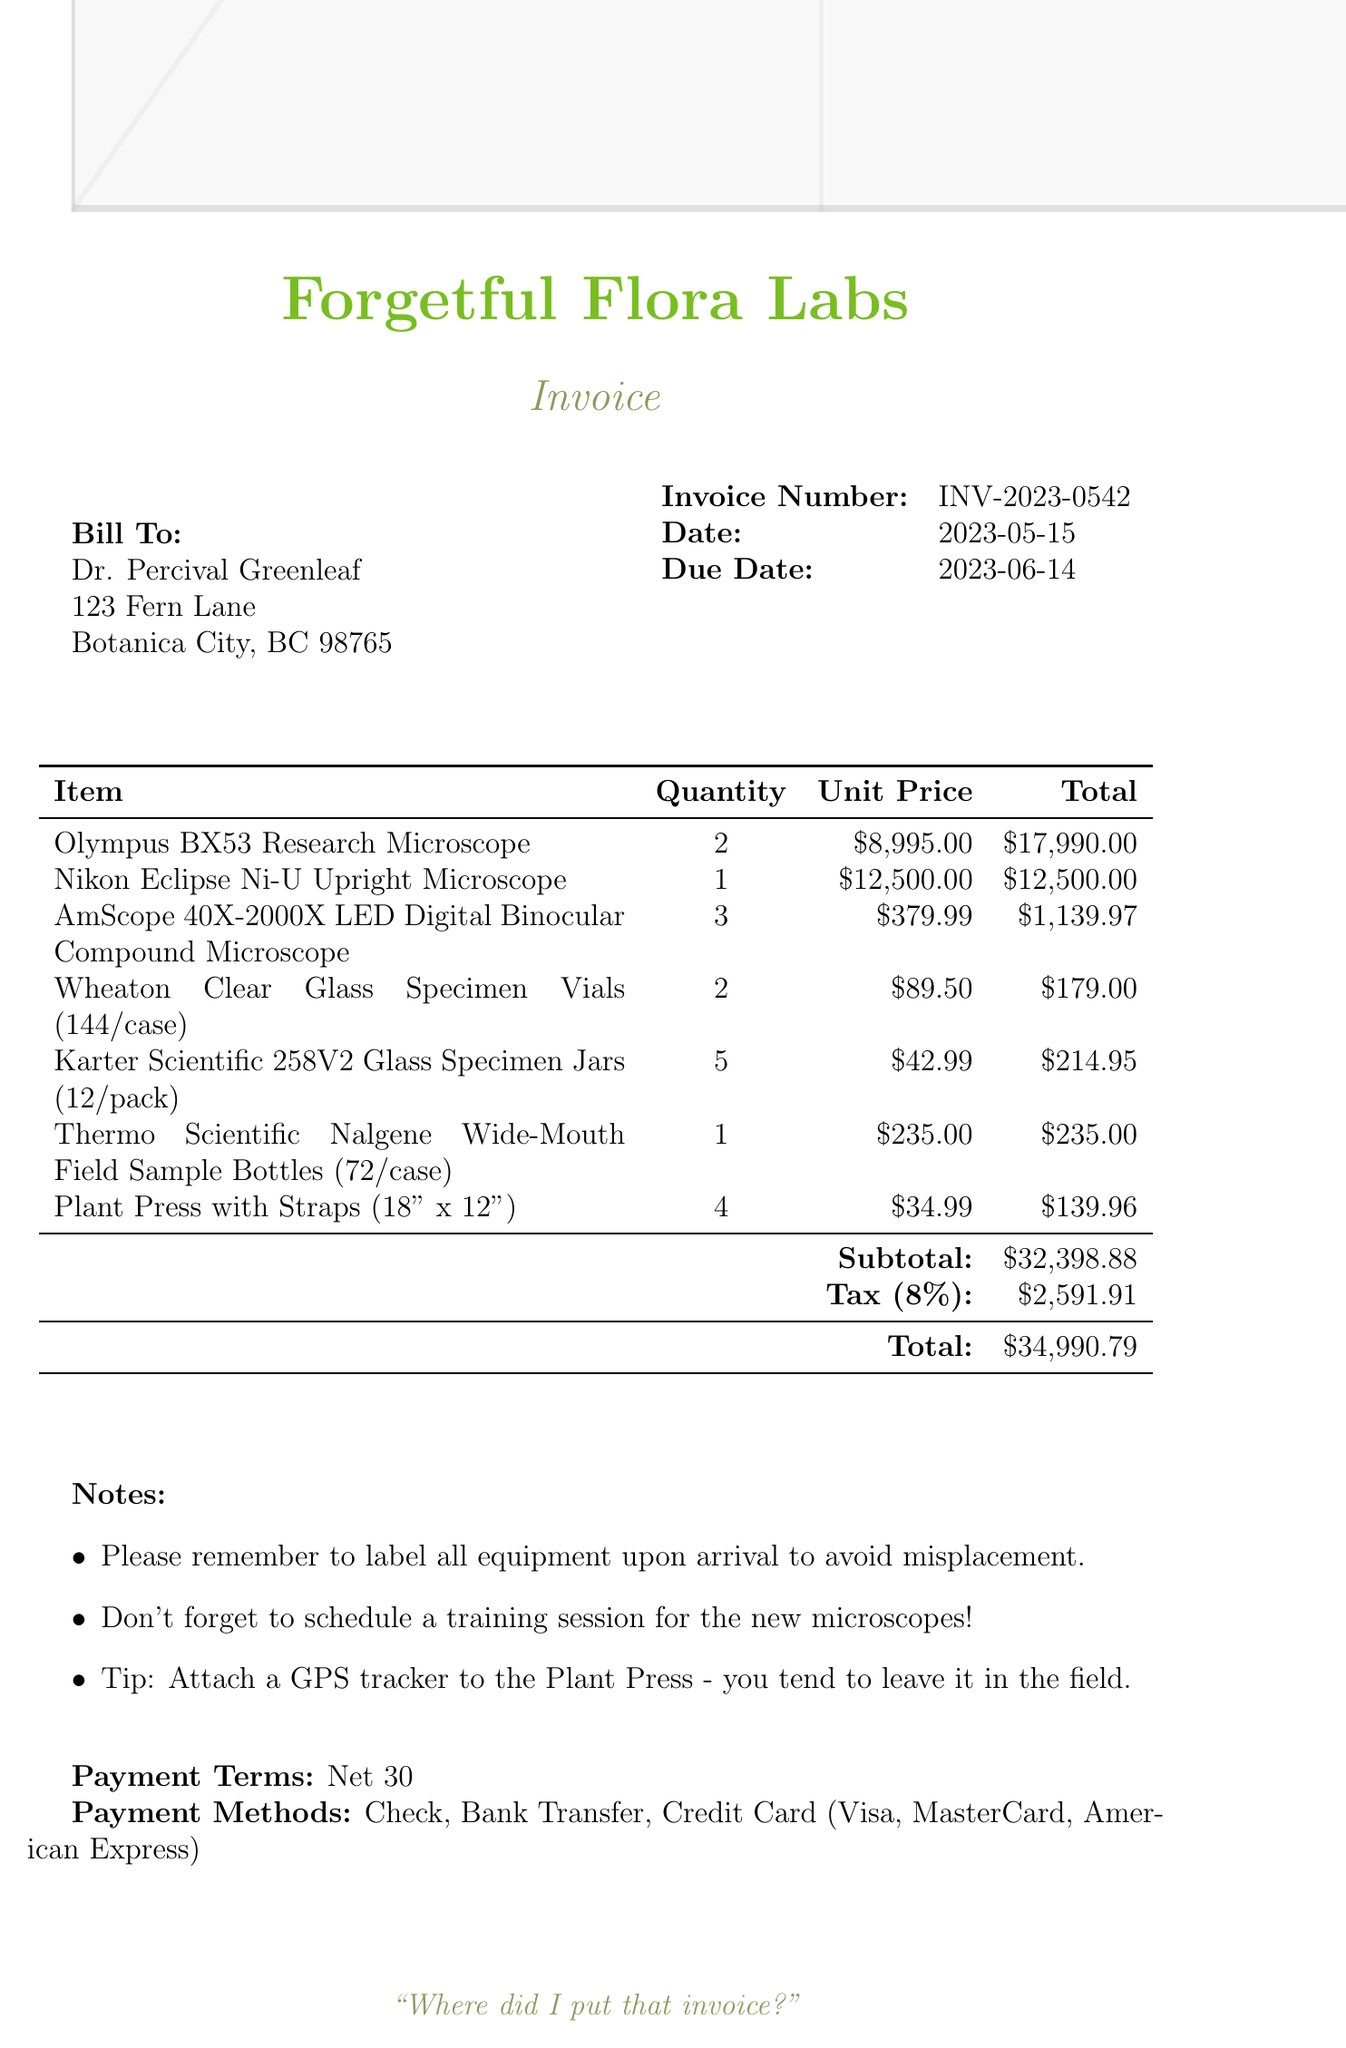What is the invoice number? The invoice number is a unique identifier for this invoice, specifically listed in the document.
Answer: INV-2023-0542 Who is the client? The client is identified by name at the beginning of the invoice, detailing to whom the invoice is addressed.
Answer: Dr. Percival Greenleaf What is the due date? The due date indicates when the payment for this invoice is required and is specified in the document.
Answer: 2023-06-14 How many Olympus BX53 Research Microscopes are listed? The quantity specifies how many units of the Olympus BX53 Research Microscope are included in the invoice.
Answer: 2 What is the subtotal amount? The subtotal refers to the total of all items before tax, explicitly stated in the document.
Answer: $32,398.88 What payment methods are accepted? The invoice lists acceptable payment methods for settling the bill, indicating the options available to the client.
Answer: Check, Bank Transfer, Credit Card (Visa, MasterCard, American Express) What is the total amount due? The total amount due is the final amount the client is required to pay, including taxes and fees, clearly stated in the invoice.
Answer: $34,990.79 What is the seller's name? The seller's name appears prominently under the seller information section of the invoice.
Answer: BotaniTech Supplies Inc What special note is included for the Plant Press? Specific notes provide additional instructions or reminders related to the equipment in the invoice.
Answer: Attach a GPS tracker to the Plant Press - you tend to leave it in the field 